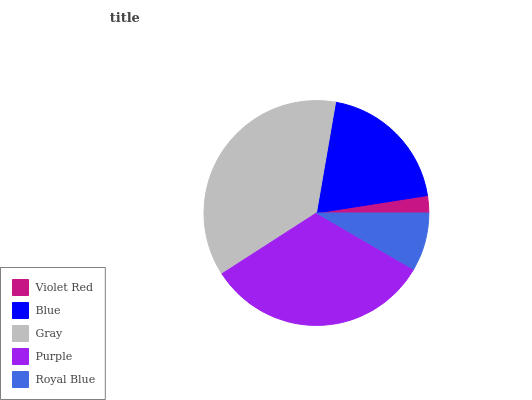Is Violet Red the minimum?
Answer yes or no. Yes. Is Gray the maximum?
Answer yes or no. Yes. Is Blue the minimum?
Answer yes or no. No. Is Blue the maximum?
Answer yes or no. No. Is Blue greater than Violet Red?
Answer yes or no. Yes. Is Violet Red less than Blue?
Answer yes or no. Yes. Is Violet Red greater than Blue?
Answer yes or no. No. Is Blue less than Violet Red?
Answer yes or no. No. Is Blue the high median?
Answer yes or no. Yes. Is Blue the low median?
Answer yes or no. Yes. Is Royal Blue the high median?
Answer yes or no. No. Is Gray the low median?
Answer yes or no. No. 